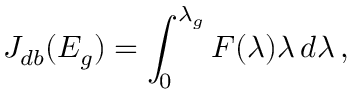<formula> <loc_0><loc_0><loc_500><loc_500>J _ { d b } ( E _ { g } ) = \int _ { 0 } ^ { \lambda _ { g } } F ( \lambda ) \lambda \, d \lambda \, ,</formula> 